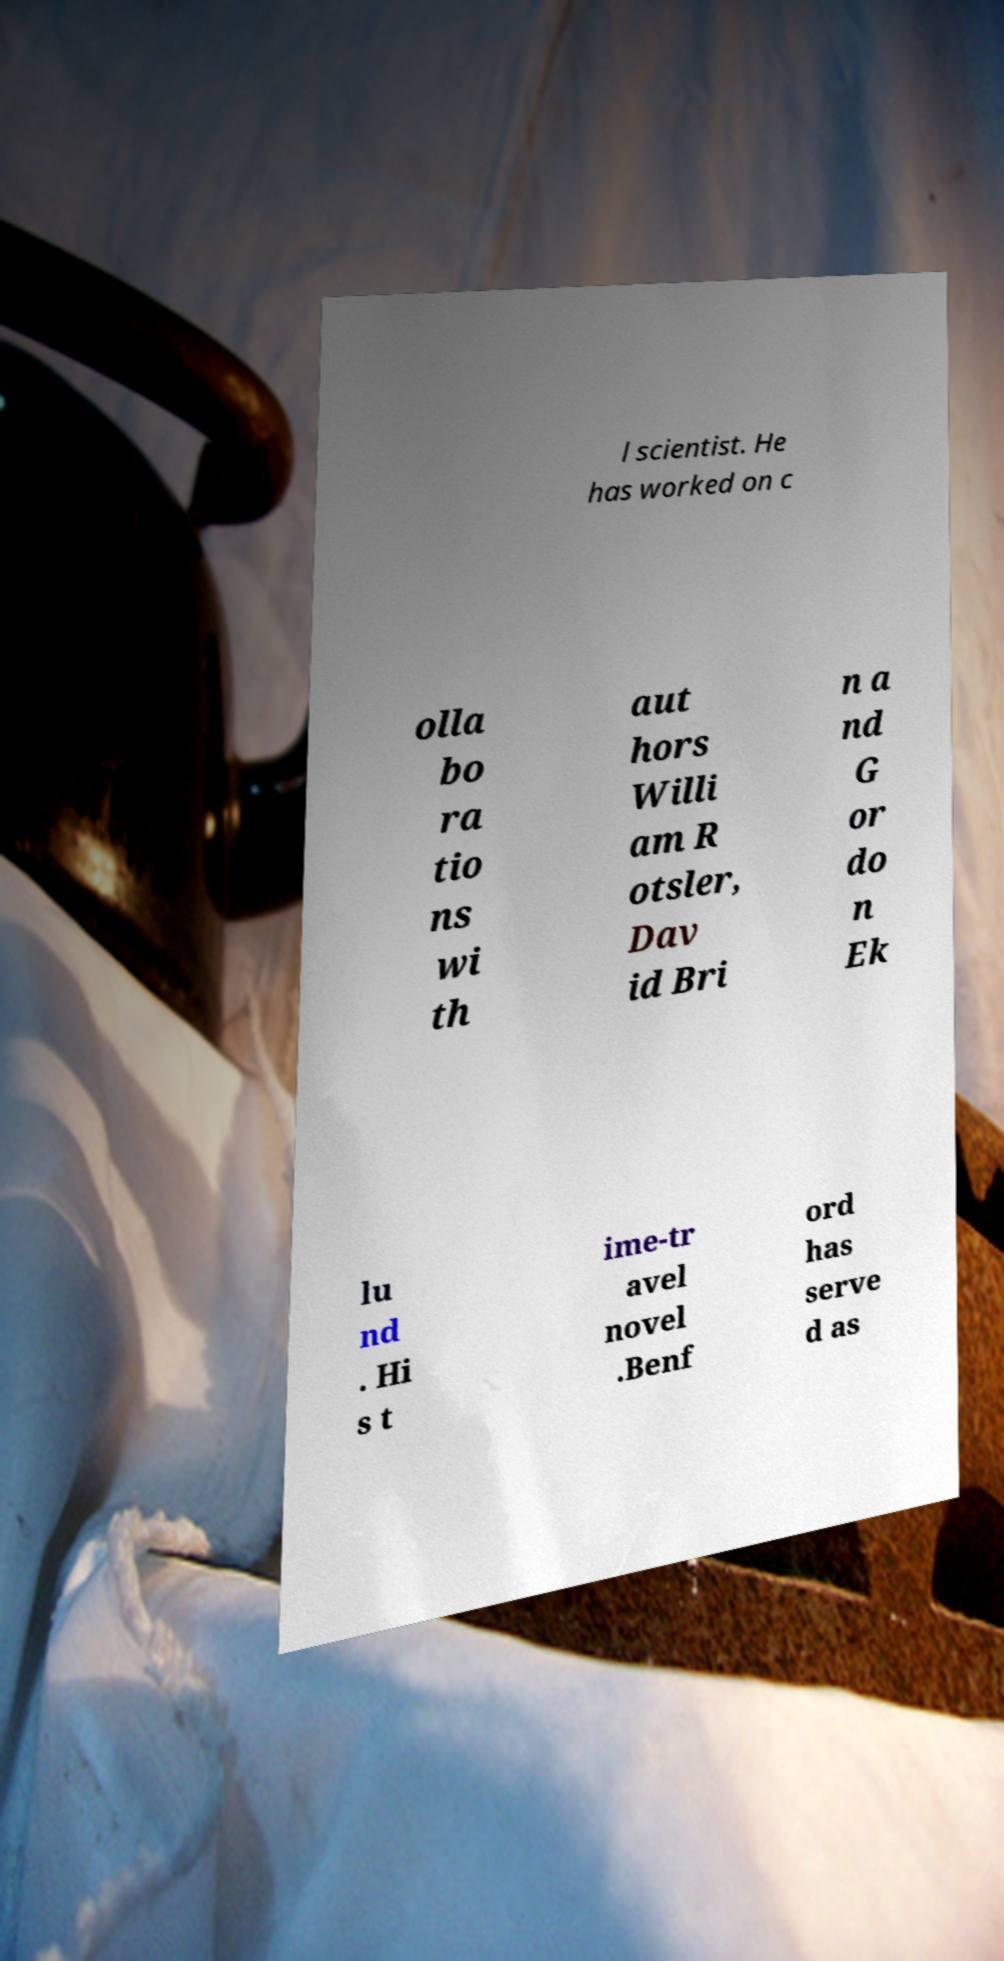Can you read and provide the text displayed in the image?This photo seems to have some interesting text. Can you extract and type it out for me? l scientist. He has worked on c olla bo ra tio ns wi th aut hors Willi am R otsler, Dav id Bri n a nd G or do n Ek lu nd . Hi s t ime-tr avel novel .Benf ord has serve d as 